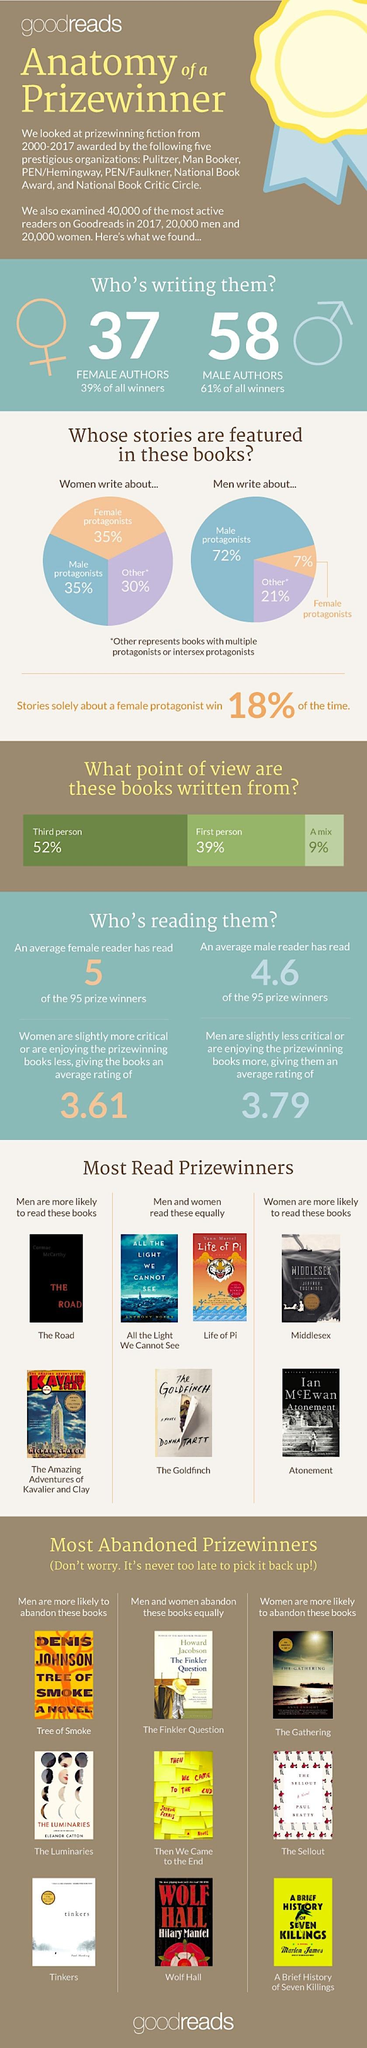List a handful of essential elements in this visual. Books with higher abandonment rates among males are likely to include Tinkers, The Luminaries, and Tree of Smoke. Research has shown that there are books that have been equally read by both male and female readers, such as 'All the Light We Cannot See', 'Life of Pi', and 'The Goldfinch'. According to data, female readers are more likely to abandon books like "The Gathering," "The Sellout," and "A brief History of Seven Killings." Books such as Middlesex and Atonement are more likely to be read by females. The share of male and female protagonists written by women is 35%. 